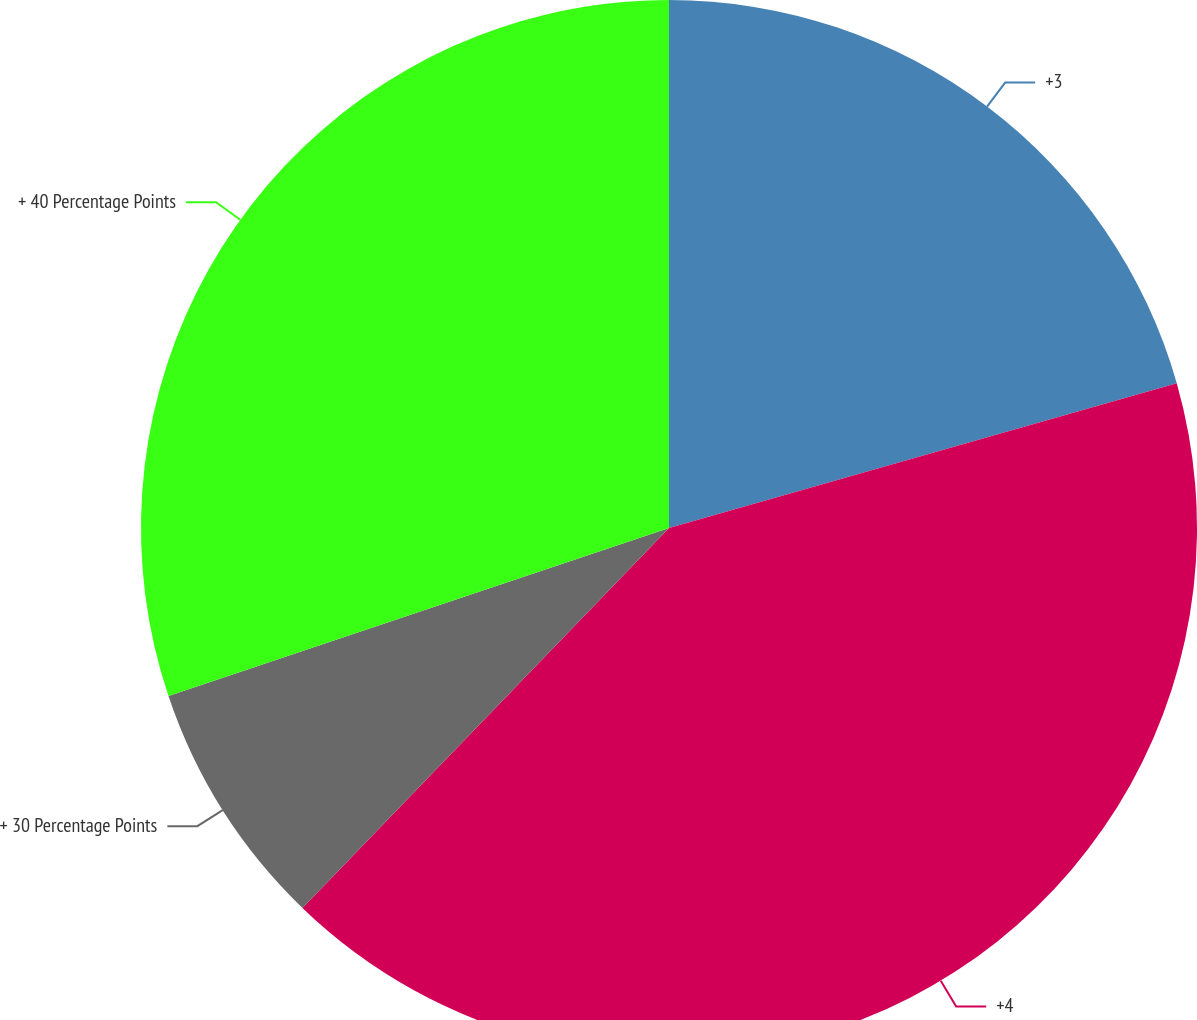Convert chart. <chart><loc_0><loc_0><loc_500><loc_500><pie_chart><fcel>+3<fcel>+4<fcel>+ 30 Percentage Points<fcel>+ 40 Percentage Points<nl><fcel>20.58%<fcel>41.64%<fcel>7.63%<fcel>30.16%<nl></chart> 